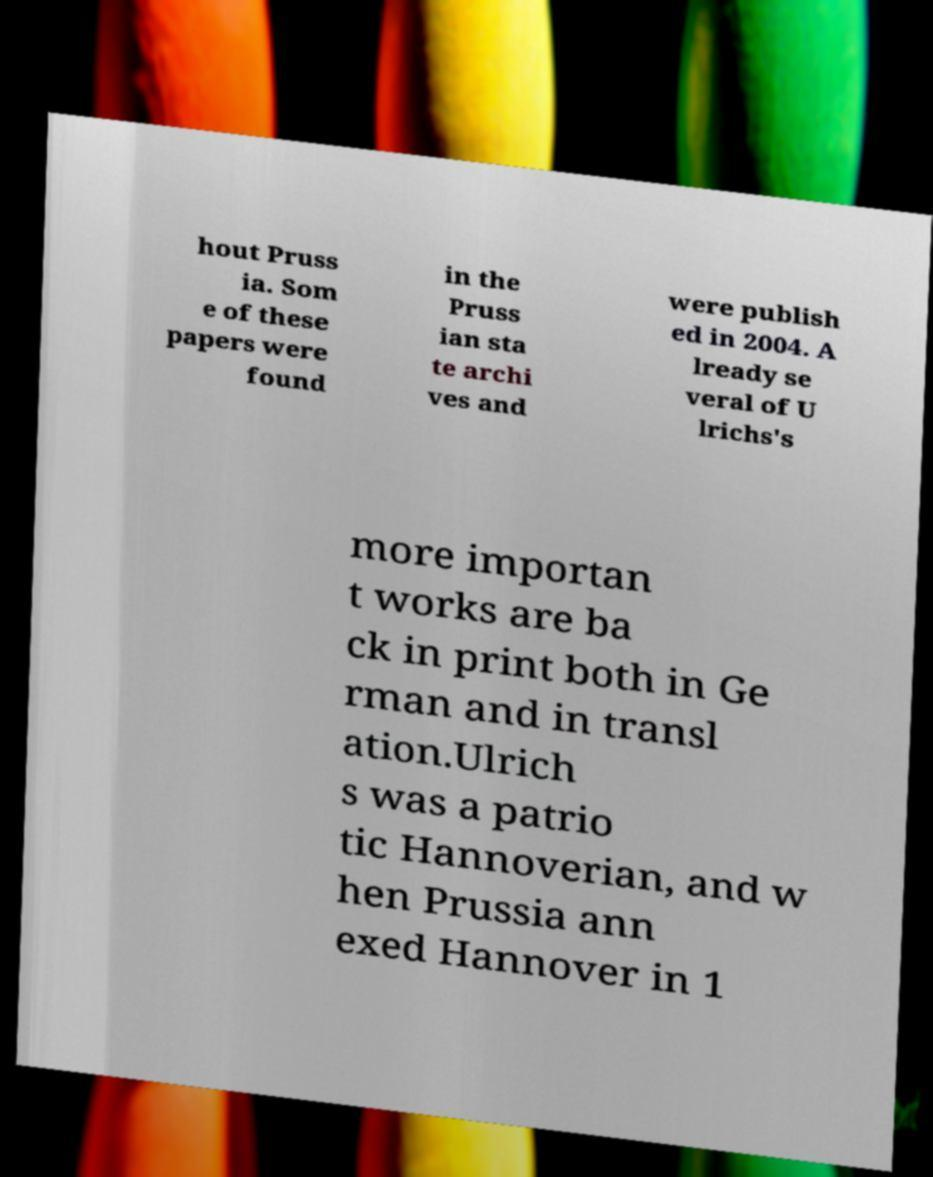Could you extract and type out the text from this image? hout Pruss ia. Som e of these papers were found in the Pruss ian sta te archi ves and were publish ed in 2004. A lready se veral of U lrichs's more importan t works are ba ck in print both in Ge rman and in transl ation.Ulrich s was a patrio tic Hannoverian, and w hen Prussia ann exed Hannover in 1 